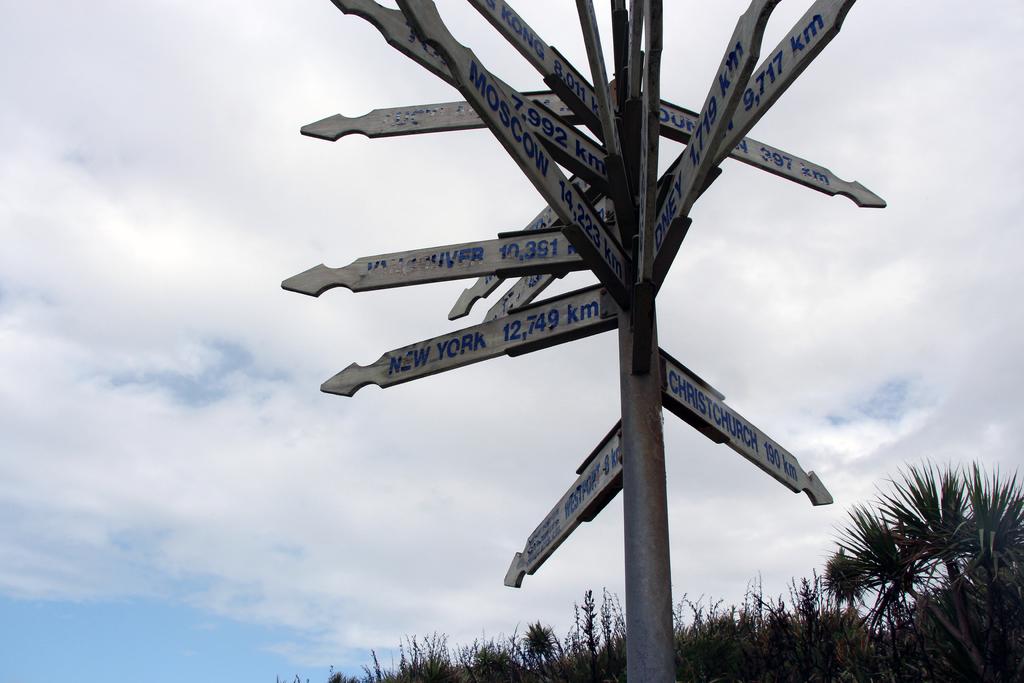Which city is 12,749 km away?
Provide a short and direct response. New york. How far to new york?
Offer a very short reply. 12749 km. 